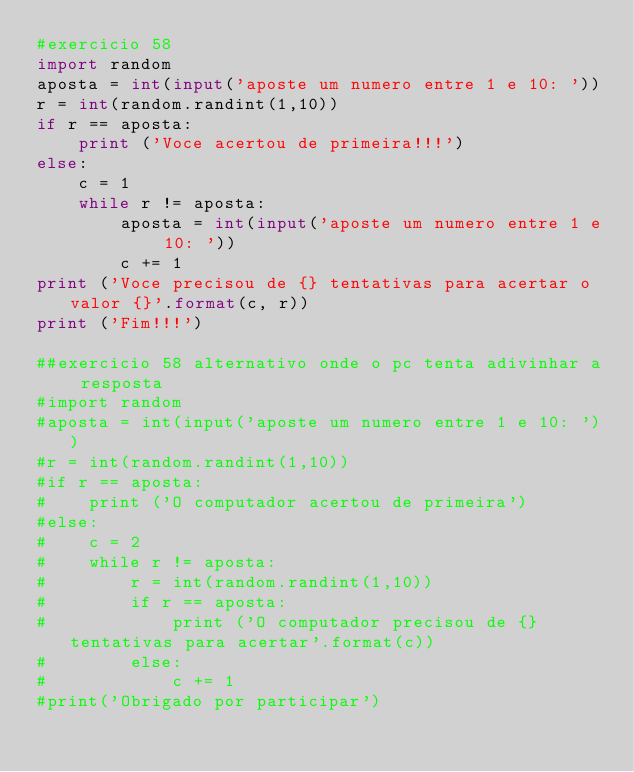<code> <loc_0><loc_0><loc_500><loc_500><_Python_>#exercicio 58
import random
aposta = int(input('aposte um numero entre 1 e 10: '))
r = int(random.randint(1,10))
if r == aposta:
    print ('Voce acertou de primeira!!!')
else:
    c = 1
    while r != aposta:
        aposta = int(input('aposte um numero entre 1 e 10: '))
        c += 1
print ('Voce precisou de {} tentativas para acertar o valor {}'.format(c, r))
print ('Fim!!!')

##exercicio 58 alternativo onde o pc tenta adivinhar a resposta
#import random
#aposta = int(input('aposte um numero entre 1 e 10: '))
#r = int(random.randint(1,10))
#if r == aposta:
#    print ('O computador acertou de primeira')
#else:
#    c = 2
#    while r != aposta:
#        r = int(random.randint(1,10))
#        if r == aposta:
#            print ('O computador precisou de {} tentativas para acertar'.format(c))
#        else:
#            c += 1
#print('Obrigado por participar')</code> 